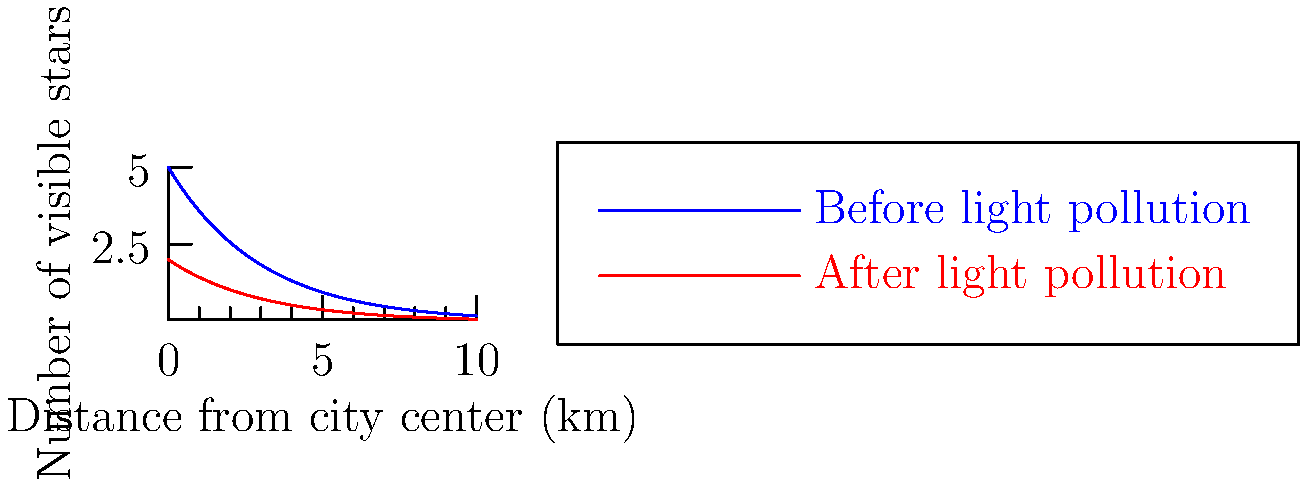The graph shows the number of visible stars as a function of distance from a city center before and after increased light pollution. At what distance from the city center does the difference in visible stars between the two scenarios become less than 1 star? To solve this problem, we need to follow these steps:

1) The "Before" scenario is represented by the function $f(x) = 5e^{-x/3}$
   The "After" scenario is represented by the function $g(x) = 2e^{-x/3}$

2) We need to find x where the difference between these functions is less than 1:
   $f(x) - g(x) < 1$

3) Substituting the functions:
   $5e^{-x/3} - 2e^{-x/3} < 1$

4) Factoring out $e^{-x/3}$:
   $e^{-x/3}(5 - 2) < 1$
   $3e^{-x/3} < 1$

5) Dividing both sides by 3:
   $e^{-x/3} < 1/3$

6) Taking the natural log of both sides:
   $-x/3 < \ln(1/3)$

7) Multiplying both sides by -3:
   $x > -3\ln(1/3)$

8) Calculating the result:
   $x > -3 * (-1.0986) \approx 3.30$ km

Therefore, at approximately 3.30 km from the city center, the difference in visible stars becomes less than 1.
Answer: 3.30 km 